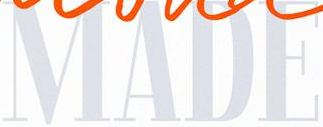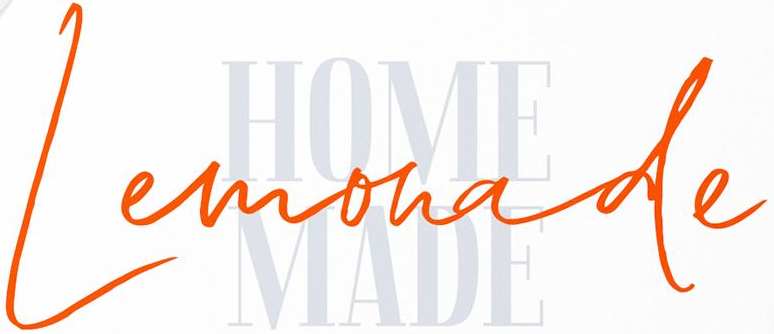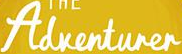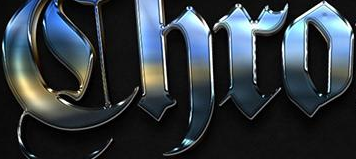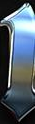What words are shown in these images in order, separated by a semicolon? MADE; Lemonade; Adventurer; Chro; # 